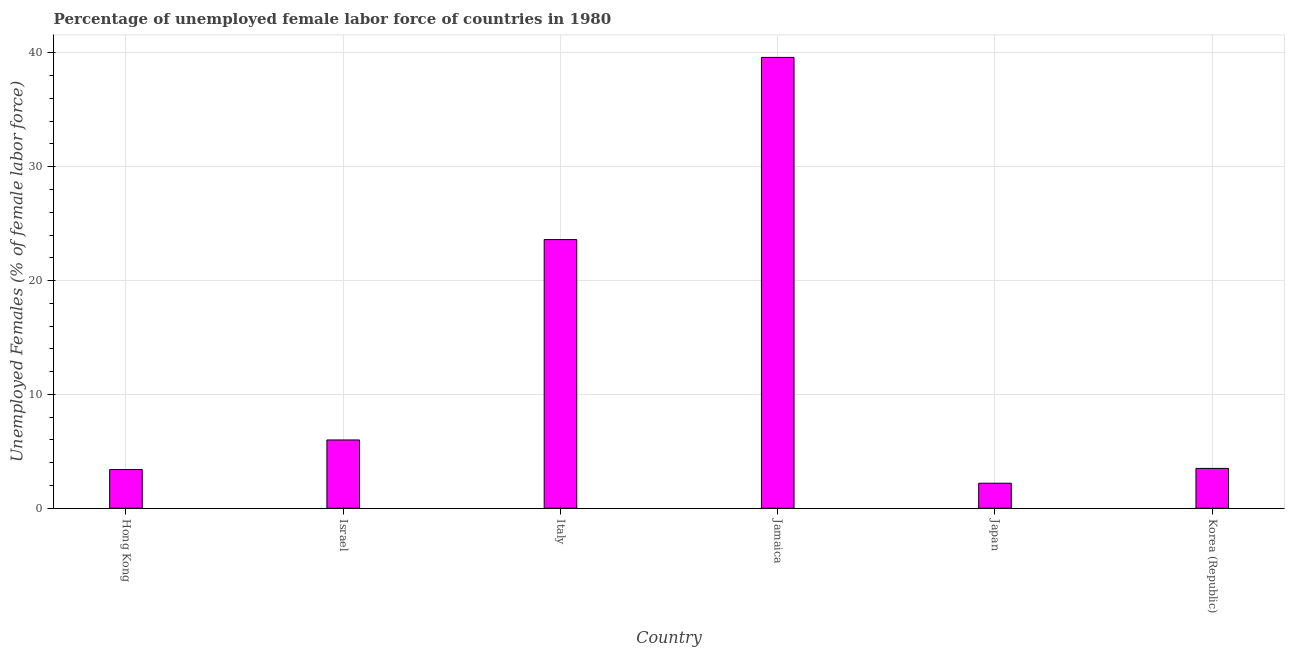What is the title of the graph?
Give a very brief answer. Percentage of unemployed female labor force of countries in 1980. What is the label or title of the Y-axis?
Give a very brief answer. Unemployed Females (% of female labor force). What is the total unemployed female labour force in Jamaica?
Your response must be concise. 39.6. Across all countries, what is the maximum total unemployed female labour force?
Offer a terse response. 39.6. Across all countries, what is the minimum total unemployed female labour force?
Provide a succinct answer. 2.2. In which country was the total unemployed female labour force maximum?
Make the answer very short. Jamaica. What is the sum of the total unemployed female labour force?
Provide a succinct answer. 78.3. What is the average total unemployed female labour force per country?
Your response must be concise. 13.05. What is the median total unemployed female labour force?
Provide a short and direct response. 4.75. In how many countries, is the total unemployed female labour force greater than 8 %?
Provide a short and direct response. 2. What is the ratio of the total unemployed female labour force in Israel to that in Korea (Republic)?
Your answer should be compact. 1.71. Is the total unemployed female labour force in Italy less than that in Korea (Republic)?
Your answer should be very brief. No. Is the difference between the total unemployed female labour force in Israel and Japan greater than the difference between any two countries?
Provide a short and direct response. No. What is the difference between the highest and the second highest total unemployed female labour force?
Offer a very short reply. 16. What is the difference between the highest and the lowest total unemployed female labour force?
Your answer should be very brief. 37.4. In how many countries, is the total unemployed female labour force greater than the average total unemployed female labour force taken over all countries?
Provide a succinct answer. 2. How many bars are there?
Make the answer very short. 6. Are all the bars in the graph horizontal?
Ensure brevity in your answer.  No. How many countries are there in the graph?
Provide a short and direct response. 6. What is the difference between two consecutive major ticks on the Y-axis?
Provide a short and direct response. 10. What is the Unemployed Females (% of female labor force) in Hong Kong?
Offer a very short reply. 3.4. What is the Unemployed Females (% of female labor force) in Israel?
Your answer should be compact. 6. What is the Unemployed Females (% of female labor force) in Italy?
Provide a short and direct response. 23.6. What is the Unemployed Females (% of female labor force) of Jamaica?
Your answer should be very brief. 39.6. What is the Unemployed Females (% of female labor force) in Japan?
Your answer should be very brief. 2.2. What is the Unemployed Females (% of female labor force) of Korea (Republic)?
Keep it short and to the point. 3.5. What is the difference between the Unemployed Females (% of female labor force) in Hong Kong and Israel?
Make the answer very short. -2.6. What is the difference between the Unemployed Females (% of female labor force) in Hong Kong and Italy?
Your response must be concise. -20.2. What is the difference between the Unemployed Females (% of female labor force) in Hong Kong and Jamaica?
Your answer should be compact. -36.2. What is the difference between the Unemployed Females (% of female labor force) in Israel and Italy?
Ensure brevity in your answer.  -17.6. What is the difference between the Unemployed Females (% of female labor force) in Israel and Jamaica?
Your response must be concise. -33.6. What is the difference between the Unemployed Females (% of female labor force) in Israel and Japan?
Your response must be concise. 3.8. What is the difference between the Unemployed Females (% of female labor force) in Israel and Korea (Republic)?
Your answer should be very brief. 2.5. What is the difference between the Unemployed Females (% of female labor force) in Italy and Jamaica?
Provide a succinct answer. -16. What is the difference between the Unemployed Females (% of female labor force) in Italy and Japan?
Keep it short and to the point. 21.4. What is the difference between the Unemployed Females (% of female labor force) in Italy and Korea (Republic)?
Provide a succinct answer. 20.1. What is the difference between the Unemployed Females (% of female labor force) in Jamaica and Japan?
Provide a short and direct response. 37.4. What is the difference between the Unemployed Females (% of female labor force) in Jamaica and Korea (Republic)?
Make the answer very short. 36.1. What is the difference between the Unemployed Females (% of female labor force) in Japan and Korea (Republic)?
Your response must be concise. -1.3. What is the ratio of the Unemployed Females (% of female labor force) in Hong Kong to that in Israel?
Make the answer very short. 0.57. What is the ratio of the Unemployed Females (% of female labor force) in Hong Kong to that in Italy?
Make the answer very short. 0.14. What is the ratio of the Unemployed Females (% of female labor force) in Hong Kong to that in Jamaica?
Make the answer very short. 0.09. What is the ratio of the Unemployed Females (% of female labor force) in Hong Kong to that in Japan?
Your answer should be compact. 1.54. What is the ratio of the Unemployed Females (% of female labor force) in Israel to that in Italy?
Offer a terse response. 0.25. What is the ratio of the Unemployed Females (% of female labor force) in Israel to that in Jamaica?
Give a very brief answer. 0.15. What is the ratio of the Unemployed Females (% of female labor force) in Israel to that in Japan?
Ensure brevity in your answer.  2.73. What is the ratio of the Unemployed Females (% of female labor force) in Israel to that in Korea (Republic)?
Provide a succinct answer. 1.71. What is the ratio of the Unemployed Females (% of female labor force) in Italy to that in Jamaica?
Ensure brevity in your answer.  0.6. What is the ratio of the Unemployed Females (% of female labor force) in Italy to that in Japan?
Give a very brief answer. 10.73. What is the ratio of the Unemployed Females (% of female labor force) in Italy to that in Korea (Republic)?
Ensure brevity in your answer.  6.74. What is the ratio of the Unemployed Females (% of female labor force) in Jamaica to that in Korea (Republic)?
Your response must be concise. 11.31. What is the ratio of the Unemployed Females (% of female labor force) in Japan to that in Korea (Republic)?
Give a very brief answer. 0.63. 